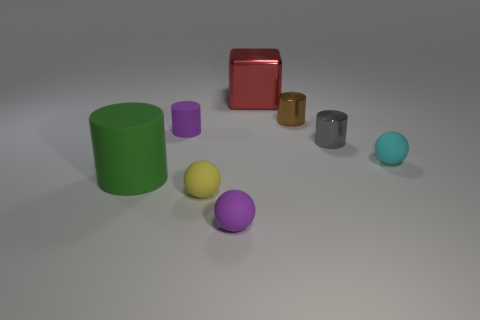Subtract all large green cylinders. How many cylinders are left? 3 Subtract 1 blocks. How many blocks are left? 0 Subtract all blocks. How many objects are left? 7 Subtract all cyan spheres. How many spheres are left? 2 Add 4 brown shiny cylinders. How many brown shiny cylinders exist? 5 Add 1 small purple matte cylinders. How many objects exist? 9 Subtract 0 blue cubes. How many objects are left? 8 Subtract all brown blocks. Subtract all blue cylinders. How many blocks are left? 1 Subtract all gray cylinders. How many green cubes are left? 0 Subtract all red shiny things. Subtract all tiny purple matte cylinders. How many objects are left? 6 